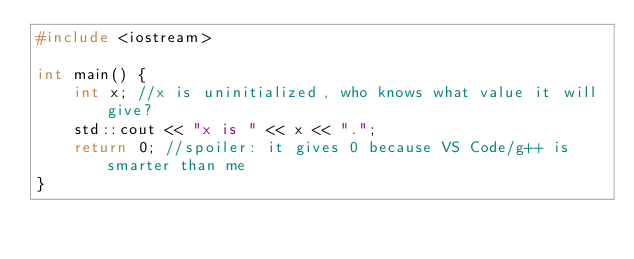<code> <loc_0><loc_0><loc_500><loc_500><_C++_>#include <iostream>

int main() {
    int x; //x is uninitialized, who knows what value it will give?
    std::cout << "x is " << x << ".";
    return 0; //spoiler: it gives 0 because VS Code/g++ is smarter than me
}</code> 